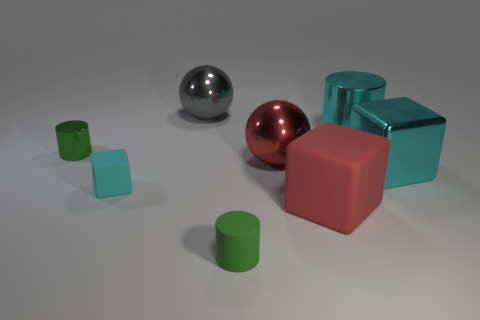What shape is the matte object that is the same color as the tiny metallic cylinder?
Give a very brief answer. Cylinder. There is a red shiny object; what shape is it?
Offer a terse response. Sphere. Are there fewer small cylinders in front of the tiny metal object than cyan cylinders?
Keep it short and to the point. No. Is there a big gray thing that has the same shape as the small green metallic object?
Your answer should be compact. No. There is a red object that is the same size as the red matte block; what shape is it?
Provide a succinct answer. Sphere. What number of things are either large shiny objects or gray balls?
Make the answer very short. 4. Is there a red cube?
Provide a short and direct response. Yes. Are there fewer cyan metallic cylinders than large gray rubber objects?
Ensure brevity in your answer.  No. Are there any metallic spheres that have the same size as the green rubber cylinder?
Give a very brief answer. No. Is the shape of the big gray object the same as the big rubber thing to the right of the green matte cylinder?
Provide a succinct answer. No. 